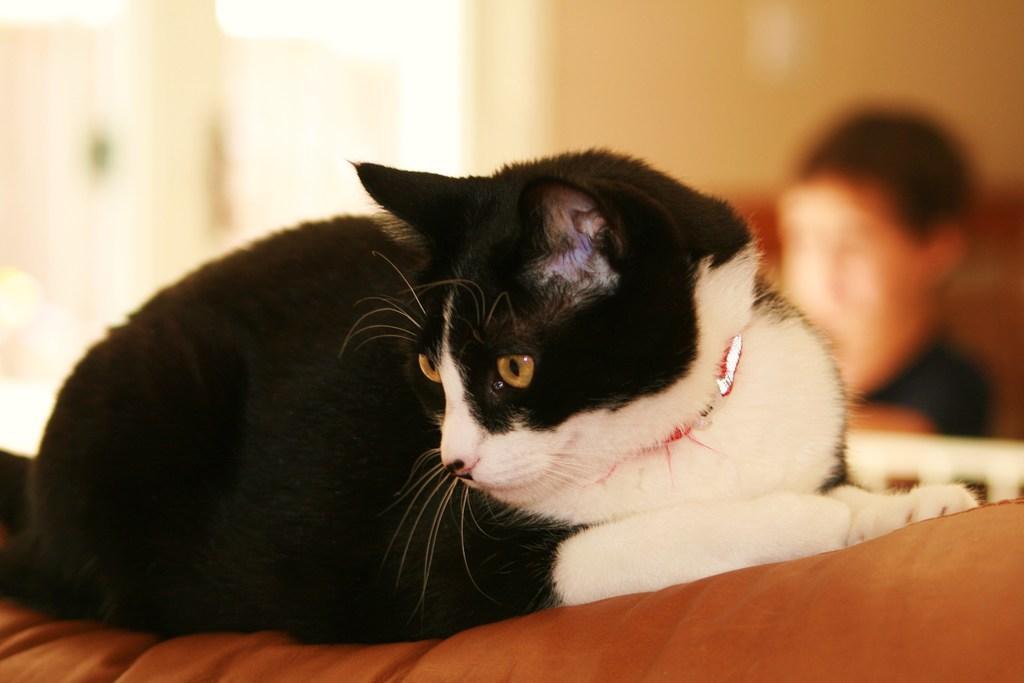Please provide a concise description of this image. In this image we can see a cat. The background of the image there is blur. We can see a person. 